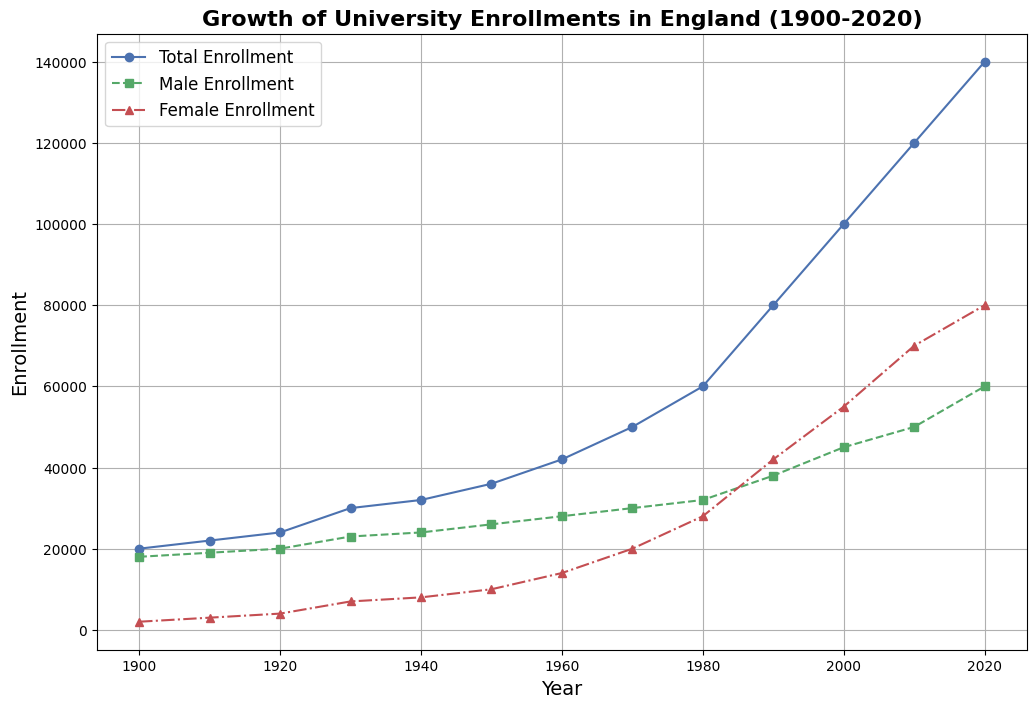Which year had the highest total enrollment? Reviewing the plot, the highest total enrollment can be identified by the peak of the "Total Enrollment" line, which is marked in blue. The highest point on this line corresponds to the year 2020.
Answer: 2020 What was the difference in male and female enrollments in 1980? In 1980, as seen on the plot, the male enrollment was marked with a green dashed line at approximately 32,000, and the female enrollment was marked with a red dash-dot line at approximately 28,000. The difference is calculated as 32,000 - 28,000.
Answer: 4,000 Between 1950 and 1960, which gender had a higher rate of increase in university enrollments? Comparing the slopes of the lines representing male and female enrollments between 1950 and 1960, the female enrollment (red dash-dot line) increased from about 10,000 to 14,000 (an increase of 4,000), while male enrollment (green dashed line) increased from 26,000 to 28,000 (an increase of 2,000). Therefore, the rate of increase was higher for female enrollment.
Answer: Female What is the average total enrollment from 1930 to 1950? The total enrollments for the years 1930, 1940, and 1950 are 30,000, 32,000, and 36,000, respectively. Summing these values gives 98,000. Dividing by the number of data points (3) provides the average: 98,000 / 3.
Answer: 32,667 Which year saw the female enrollment surpass the male enrollment for the first time? Observing the points where the red and green lines intersect, the female enrollment surpasses male enrollment in 1990 for the first time, as visible from the chart.
Answer: 1990 How much did total enrollment grow from 2000 to 2020? The total enrollment in 2000 was 100,000 and increased to 140,000 in 2020. The growth is calculated as 140,000 - 100,000.
Answer: 40,000 Was there any decade where the female enrollment remained constant or decreased? Observing the red dash-dot line, it consistently increases over each decade without any constant or decreasing trend.
Answer: No Comparing the total enrollment in 1910 and 2010, how many times larger was the enrollment in 2010? The total enrollment in 1910 was 22,000, and in 2010 it was 120,000. To find how many times larger 2010's enrollment was compared to 1910, divide 120,000 by 22,000.
Answer: Approximately 5.45 In which decade did both male and female enrollments show the most significant growth? By analyzing the steepest slopes for both the green (male enrollment) and red (female enrollment) lines, the decade from 1980 to 1990 shows the most significant growth for both genders.
Answer: 1980-1990 What is the general trend of female enrollment from 1900 to 2020? The red dash-dot line representing female enrollment shows a consistent increase from 2,000 in 1900 to 80,000 in 2020, indicating a steady rise over the decades.
Answer: Increasing 